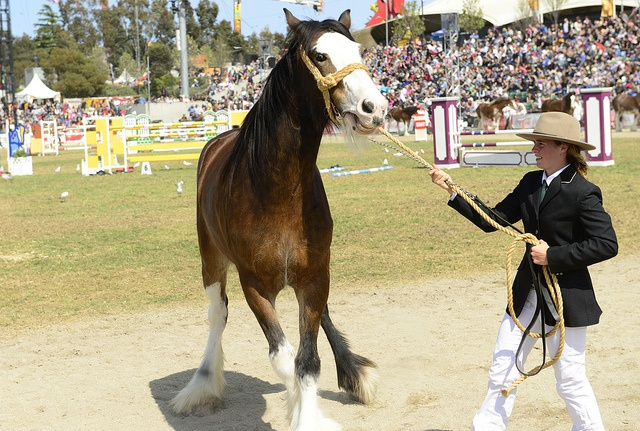Describe the objects in this image and their specific colors. I can see horse in gray, black, maroon, and ivory tones, people in gray, lightgray, darkgray, and black tones, people in gray, black, white, tan, and darkgray tones, people in gray, darkgray, white, and black tones, and tie in gray, black, and teal tones in this image. 